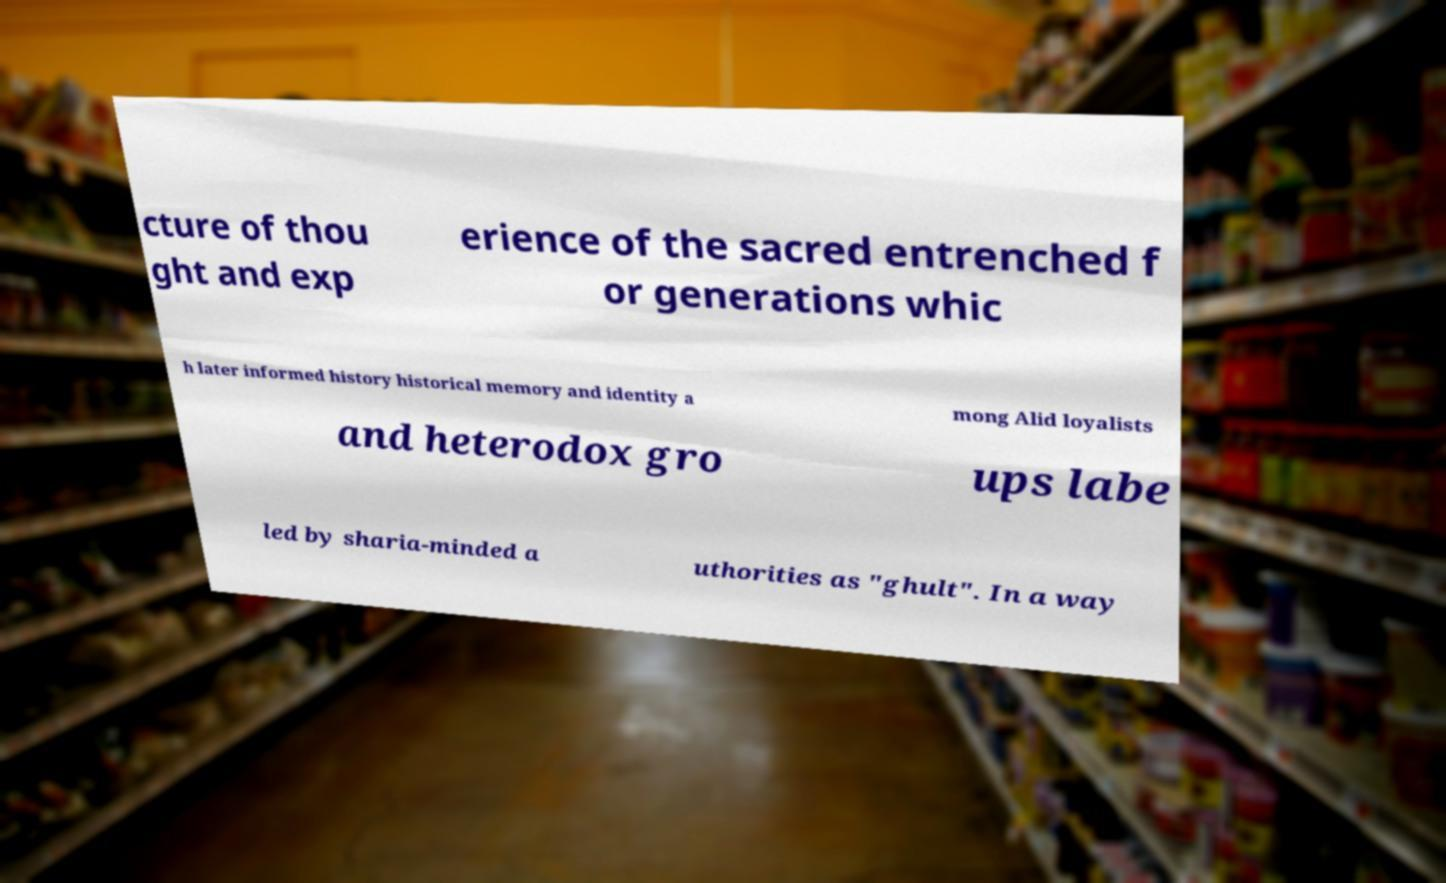Could you extract and type out the text from this image? cture of thou ght and exp erience of the sacred entrenched f or generations whic h later informed history historical memory and identity a mong Alid loyalists and heterodox gro ups labe led by sharia-minded a uthorities as "ghult". In a way 